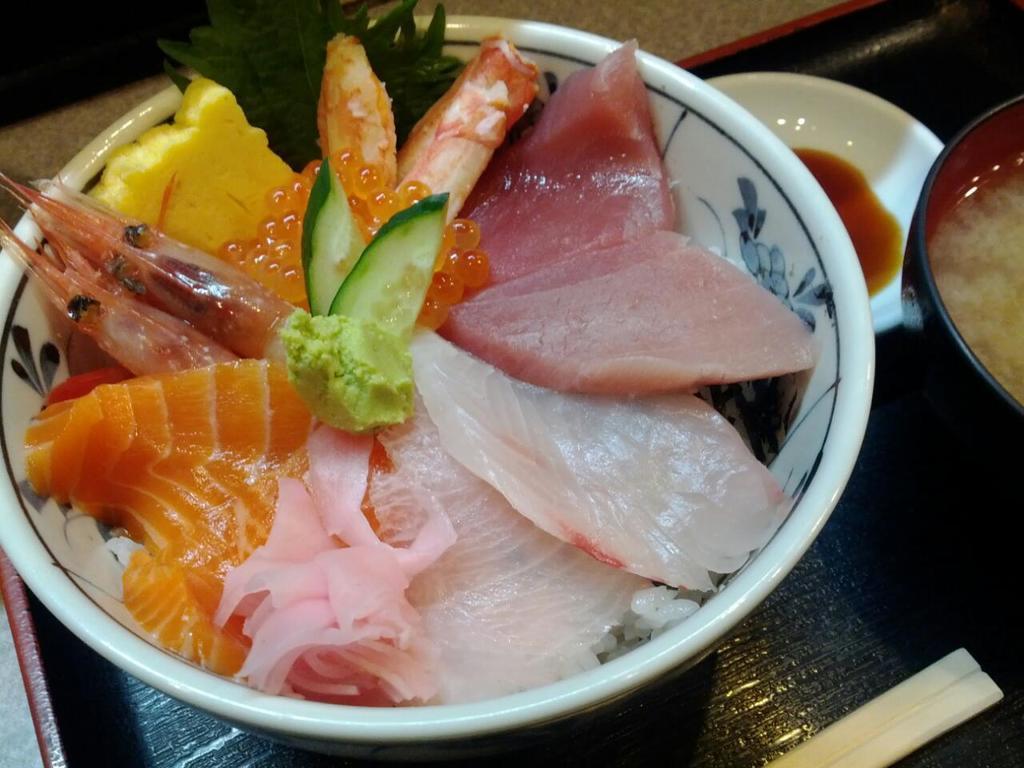Can you describe this image briefly? In this image we can see there are some food items placed on a table. 